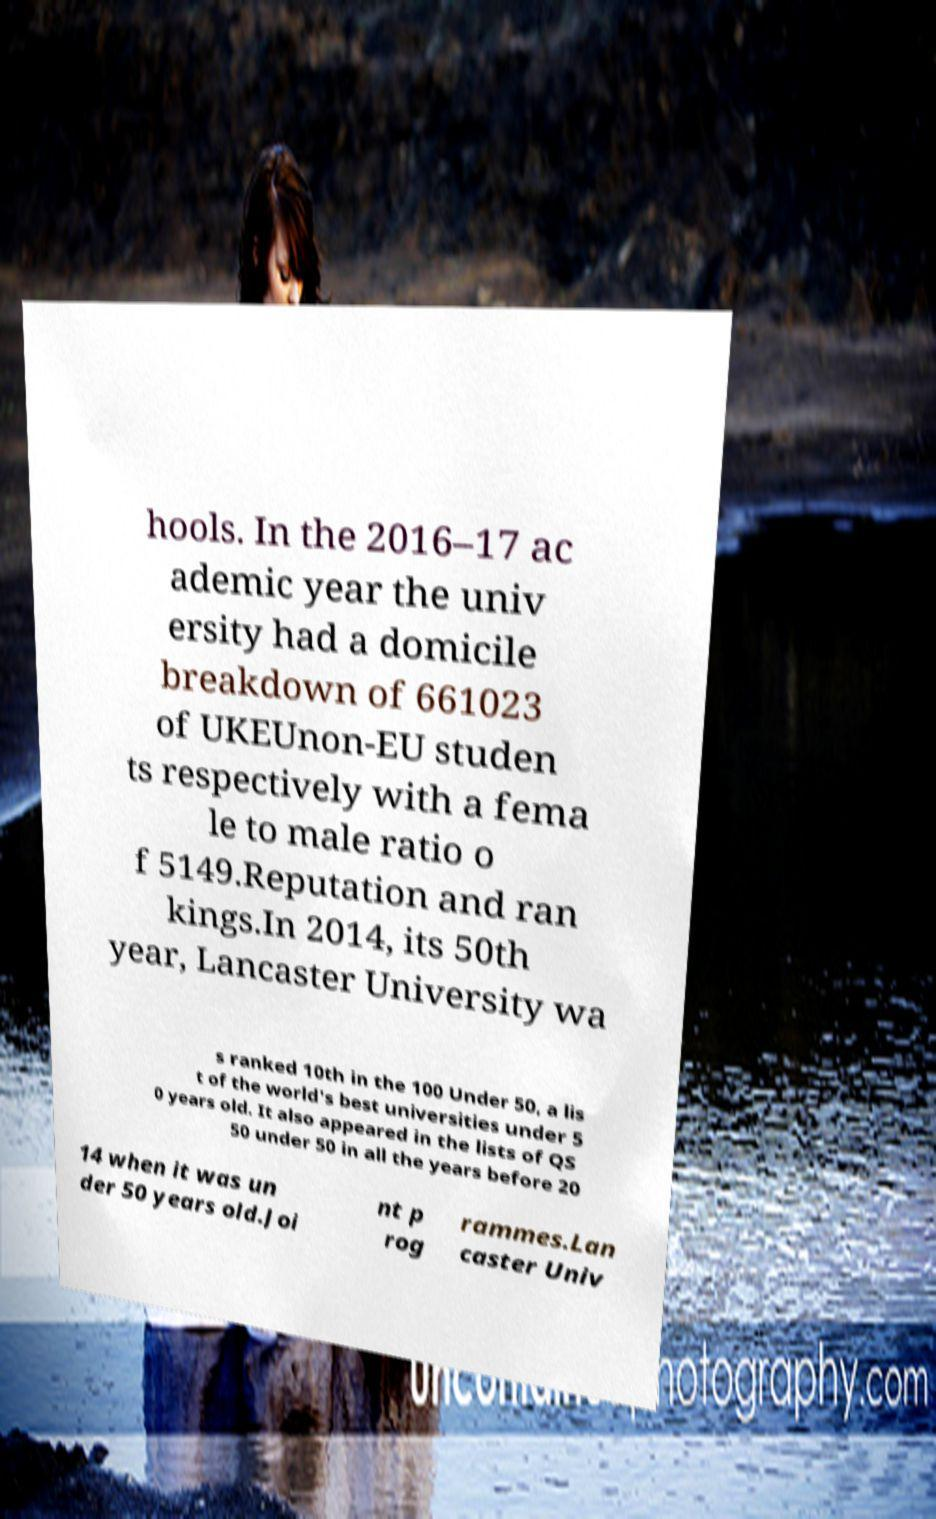There's text embedded in this image that I need extracted. Can you transcribe it verbatim? hools. In the 2016–17 ac ademic year the univ ersity had a domicile breakdown of 661023 of UKEUnon-EU studen ts respectively with a fema le to male ratio o f 5149.Reputation and ran kings.In 2014, its 50th year, Lancaster University wa s ranked 10th in the 100 Under 50, a lis t of the world's best universities under 5 0 years old. It also appeared in the lists of QS 50 under 50 in all the years before 20 14 when it was un der 50 years old.Joi nt p rog rammes.Lan caster Univ 